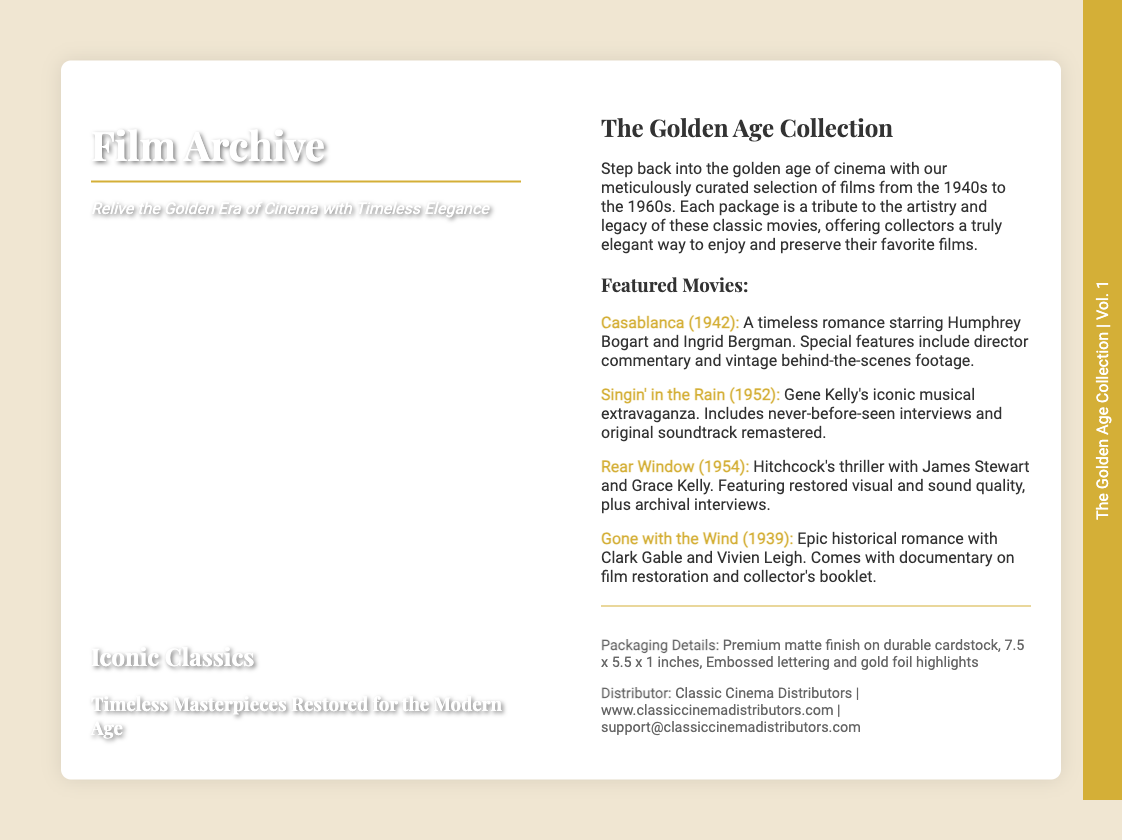What is the title of the collection? The title of the collection is mentioned prominently on the back cover as "The Golden Age Collection."
Answer: The Golden Age Collection What are the dimensions of the packaging? The packaging details state the dimensions to be 7.5 x 5.5 x 1 inches.
Answer: 7.5 x 5.5 x 1 inches Which movie features a romantic pairing of Humphrey Bogart and Ingrid Bergman? The document specifies "Casablanca" as the movie starring Humphrey Bogart and Ingrid Bergman.
Answer: Casablanca What is the tagline of the product? The tagline is highlighted in the front cover part as "Relive the Golden Era of Cinema with Timeless Elegance."
Answer: Relive the Golden Era of Cinema with Timeless Elegance How many featured movies are listed? The document lists a total of four featured movies under the "Featured Movies" heading.
Answer: Four What is included in the "Gone with the Wind" special features? The special features mentioned for "Gone with the Wind" include a documentary on film restoration and a collector's booklet.
Answer: Documentary on film restoration and collector's booklet Who is the distributor of the product? The distributor information can be found at the end of the document, named as "Classic Cinema Distributors."
Answer: Classic Cinema Distributors What year was "Singin' in the Rain" released? The document specifies that "Singin' in the Rain" was released in 1952.
Answer: 1952 